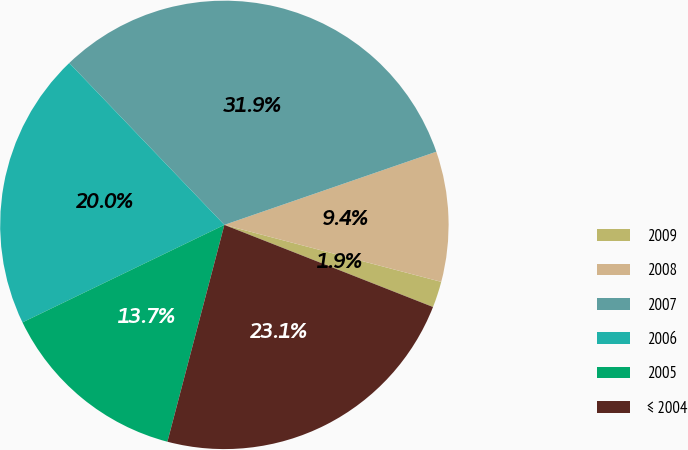<chart> <loc_0><loc_0><loc_500><loc_500><pie_chart><fcel>2009<fcel>2008<fcel>2007<fcel>2006<fcel>2005<fcel>≤ 2004<nl><fcel>1.88%<fcel>9.38%<fcel>31.87%<fcel>20.0%<fcel>13.75%<fcel>23.12%<nl></chart> 